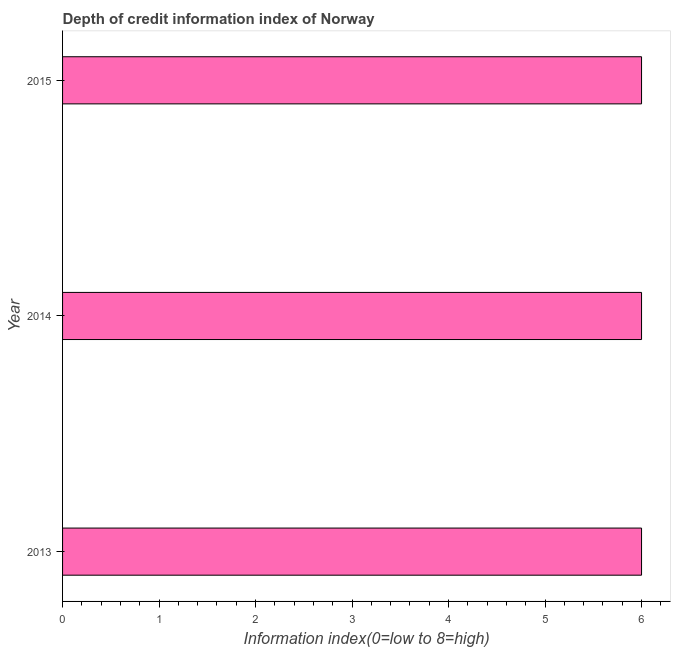Does the graph contain grids?
Make the answer very short. No. What is the title of the graph?
Your response must be concise. Depth of credit information index of Norway. What is the label or title of the X-axis?
Keep it short and to the point. Information index(0=low to 8=high). What is the label or title of the Y-axis?
Provide a short and direct response. Year. What is the depth of credit information index in 2014?
Offer a very short reply. 6. Across all years, what is the maximum depth of credit information index?
Give a very brief answer. 6. Across all years, what is the minimum depth of credit information index?
Offer a terse response. 6. In which year was the depth of credit information index maximum?
Provide a succinct answer. 2013. What is the sum of the depth of credit information index?
Make the answer very short. 18. What is the median depth of credit information index?
Your answer should be very brief. 6. Do a majority of the years between 2015 and 2014 (inclusive) have depth of credit information index greater than 5 ?
Your answer should be compact. No. Is the depth of credit information index in 2014 less than that in 2015?
Give a very brief answer. No. Is the difference between the depth of credit information index in 2014 and 2015 greater than the difference between any two years?
Your response must be concise. Yes. What is the difference between the highest and the second highest depth of credit information index?
Ensure brevity in your answer.  0. In how many years, is the depth of credit information index greater than the average depth of credit information index taken over all years?
Your response must be concise. 0. Are all the bars in the graph horizontal?
Offer a very short reply. Yes. How many years are there in the graph?
Provide a short and direct response. 3. What is the difference between two consecutive major ticks on the X-axis?
Your response must be concise. 1. Are the values on the major ticks of X-axis written in scientific E-notation?
Offer a terse response. No. What is the difference between the Information index(0=low to 8=high) in 2013 and 2014?
Ensure brevity in your answer.  0. What is the difference between the Information index(0=low to 8=high) in 2013 and 2015?
Give a very brief answer. 0. What is the difference between the Information index(0=low to 8=high) in 2014 and 2015?
Provide a short and direct response. 0. What is the ratio of the Information index(0=low to 8=high) in 2013 to that in 2014?
Keep it short and to the point. 1. What is the ratio of the Information index(0=low to 8=high) in 2013 to that in 2015?
Your answer should be very brief. 1. What is the ratio of the Information index(0=low to 8=high) in 2014 to that in 2015?
Give a very brief answer. 1. 